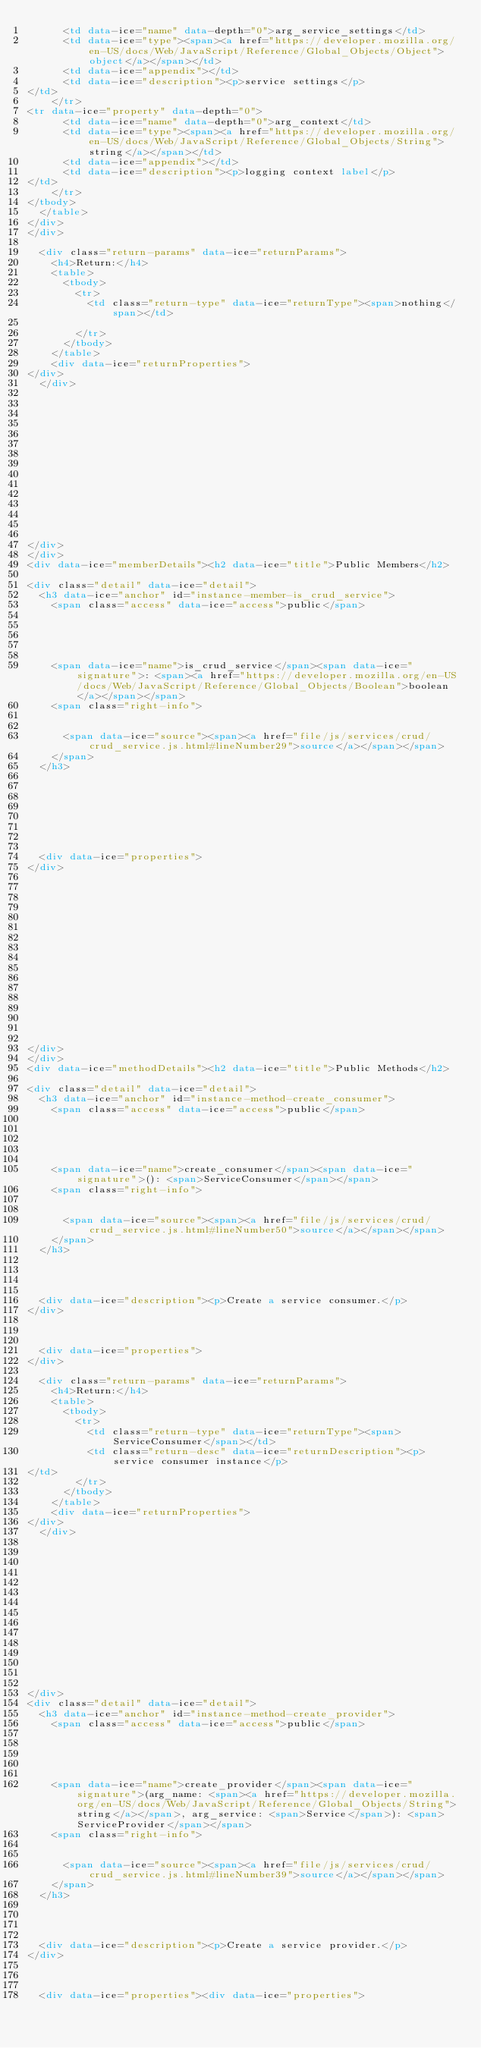<code> <loc_0><loc_0><loc_500><loc_500><_HTML_>      <td data-ice="name" data-depth="0">arg_service_settings</td>
      <td data-ice="type"><span><a href="https://developer.mozilla.org/en-US/docs/Web/JavaScript/Reference/Global_Objects/Object">object</a></span></td>
      <td data-ice="appendix"></td>
      <td data-ice="description"><p>service settings</p>
</td>
    </tr>
<tr data-ice="property" data-depth="0">
      <td data-ice="name" data-depth="0">arg_context</td>
      <td data-ice="type"><span><a href="https://developer.mozilla.org/en-US/docs/Web/JavaScript/Reference/Global_Objects/String">string</a></span></td>
      <td data-ice="appendix"></td>
      <td data-ice="description"><p>logging context label</p>
</td>
    </tr>
</tbody>
  </table>
</div>
</div>

  <div class="return-params" data-ice="returnParams">
    <h4>Return:</h4>
    <table>
      <tbody>
        <tr>
          <td class="return-type" data-ice="returnType"><span>nothing</span></td>
          
        </tr>
      </tbody>
    </table>
    <div data-ice="returnProperties">
</div>
  </div>

  

  

  

  

  

  

  
  
</div>
</div>
<div data-ice="memberDetails"><h2 data-ice="title">Public Members</h2>

<div class="detail" data-ice="detail">
  <h3 data-ice="anchor" id="instance-member-is_crud_service">
    <span class="access" data-ice="access">public</span>
    
    
    
    
    
    <span data-ice="name">is_crud_service</span><span data-ice="signature">: <span><a href="https://developer.mozilla.org/en-US/docs/Web/JavaScript/Reference/Global_Objects/Boolean">boolean</a></span></span>
    <span class="right-info">
      
      
      <span data-ice="source"><span><a href="file/js/services/crud/crud_service.js.html#lineNumber29">source</a></span></span>
    </span>
  </h3>

  
  
  
  

  

  <div data-ice="properties">
</div>

  

  

  

  

  

  

  

  
  
</div>
</div>
<div data-ice="methodDetails"><h2 data-ice="title">Public Methods</h2>

<div class="detail" data-ice="detail">
  <h3 data-ice="anchor" id="instance-method-create_consumer">
    <span class="access" data-ice="access">public</span>
    
    
    
    
    
    <span data-ice="name">create_consumer</span><span data-ice="signature">(): <span>ServiceConsumer</span></span>
    <span class="right-info">
      
      
      <span data-ice="source"><span><a href="file/js/services/crud/crud_service.js.html#lineNumber50">source</a></span></span>
    </span>
  </h3>

  
  
  
  <div data-ice="description"><p>Create a service consumer.</p>
</div>

  

  <div data-ice="properties">
</div>

  <div class="return-params" data-ice="returnParams">
    <h4>Return:</h4>
    <table>
      <tbody>
        <tr>
          <td class="return-type" data-ice="returnType"><span>ServiceConsumer</span></td>
          <td class="return-desc" data-ice="returnDescription"><p>service consumer instance</p>
</td>
        </tr>
      </tbody>
    </table>
    <div data-ice="returnProperties">
</div>
  </div>

  

  

  

  

  

  

  
  
</div>
<div class="detail" data-ice="detail">
  <h3 data-ice="anchor" id="instance-method-create_provider">
    <span class="access" data-ice="access">public</span>
    
    
    
    
    
    <span data-ice="name">create_provider</span><span data-ice="signature">(arg_name: <span><a href="https://developer.mozilla.org/en-US/docs/Web/JavaScript/Reference/Global_Objects/String">string</a></span>, arg_service: <span>Service</span>): <span>ServiceProvider</span></span>
    <span class="right-info">
      
      
      <span data-ice="source"><span><a href="file/js/services/crud/crud_service.js.html#lineNumber39">source</a></span></span>
    </span>
  </h3>

  
  
  
  <div data-ice="description"><p>Create a service provider.</p>
</div>

  

  <div data-ice="properties"><div data-ice="properties"></code> 